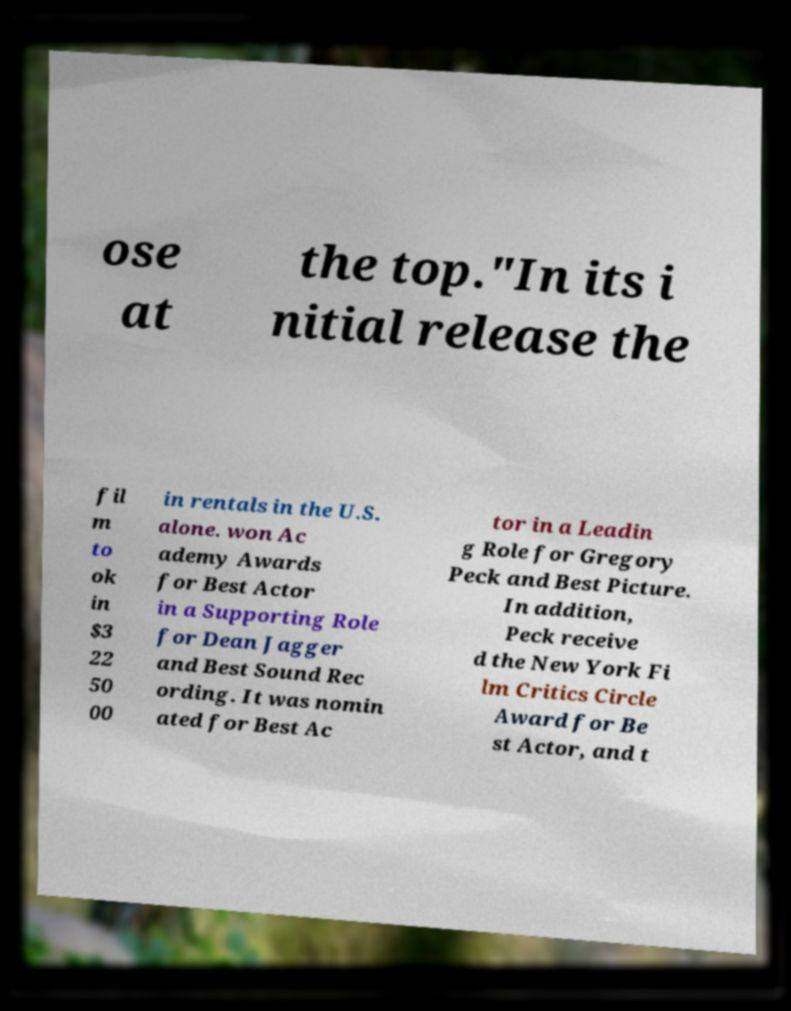For documentation purposes, I need the text within this image transcribed. Could you provide that? ose at the top."In its i nitial release the fil m to ok in $3 22 50 00 in rentals in the U.S. alone. won Ac ademy Awards for Best Actor in a Supporting Role for Dean Jagger and Best Sound Rec ording. It was nomin ated for Best Ac tor in a Leadin g Role for Gregory Peck and Best Picture. In addition, Peck receive d the New York Fi lm Critics Circle Award for Be st Actor, and t 